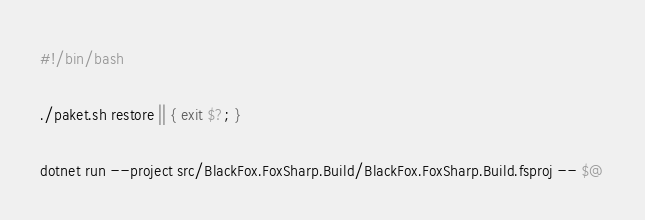Convert code to text. <code><loc_0><loc_0><loc_500><loc_500><_Bash_>#!/bin/bash

./paket.sh restore || { exit $?; }

dotnet run --project src/BlackFox.FoxSharp.Build/BlackFox.FoxSharp.Build.fsproj -- $@
</code> 